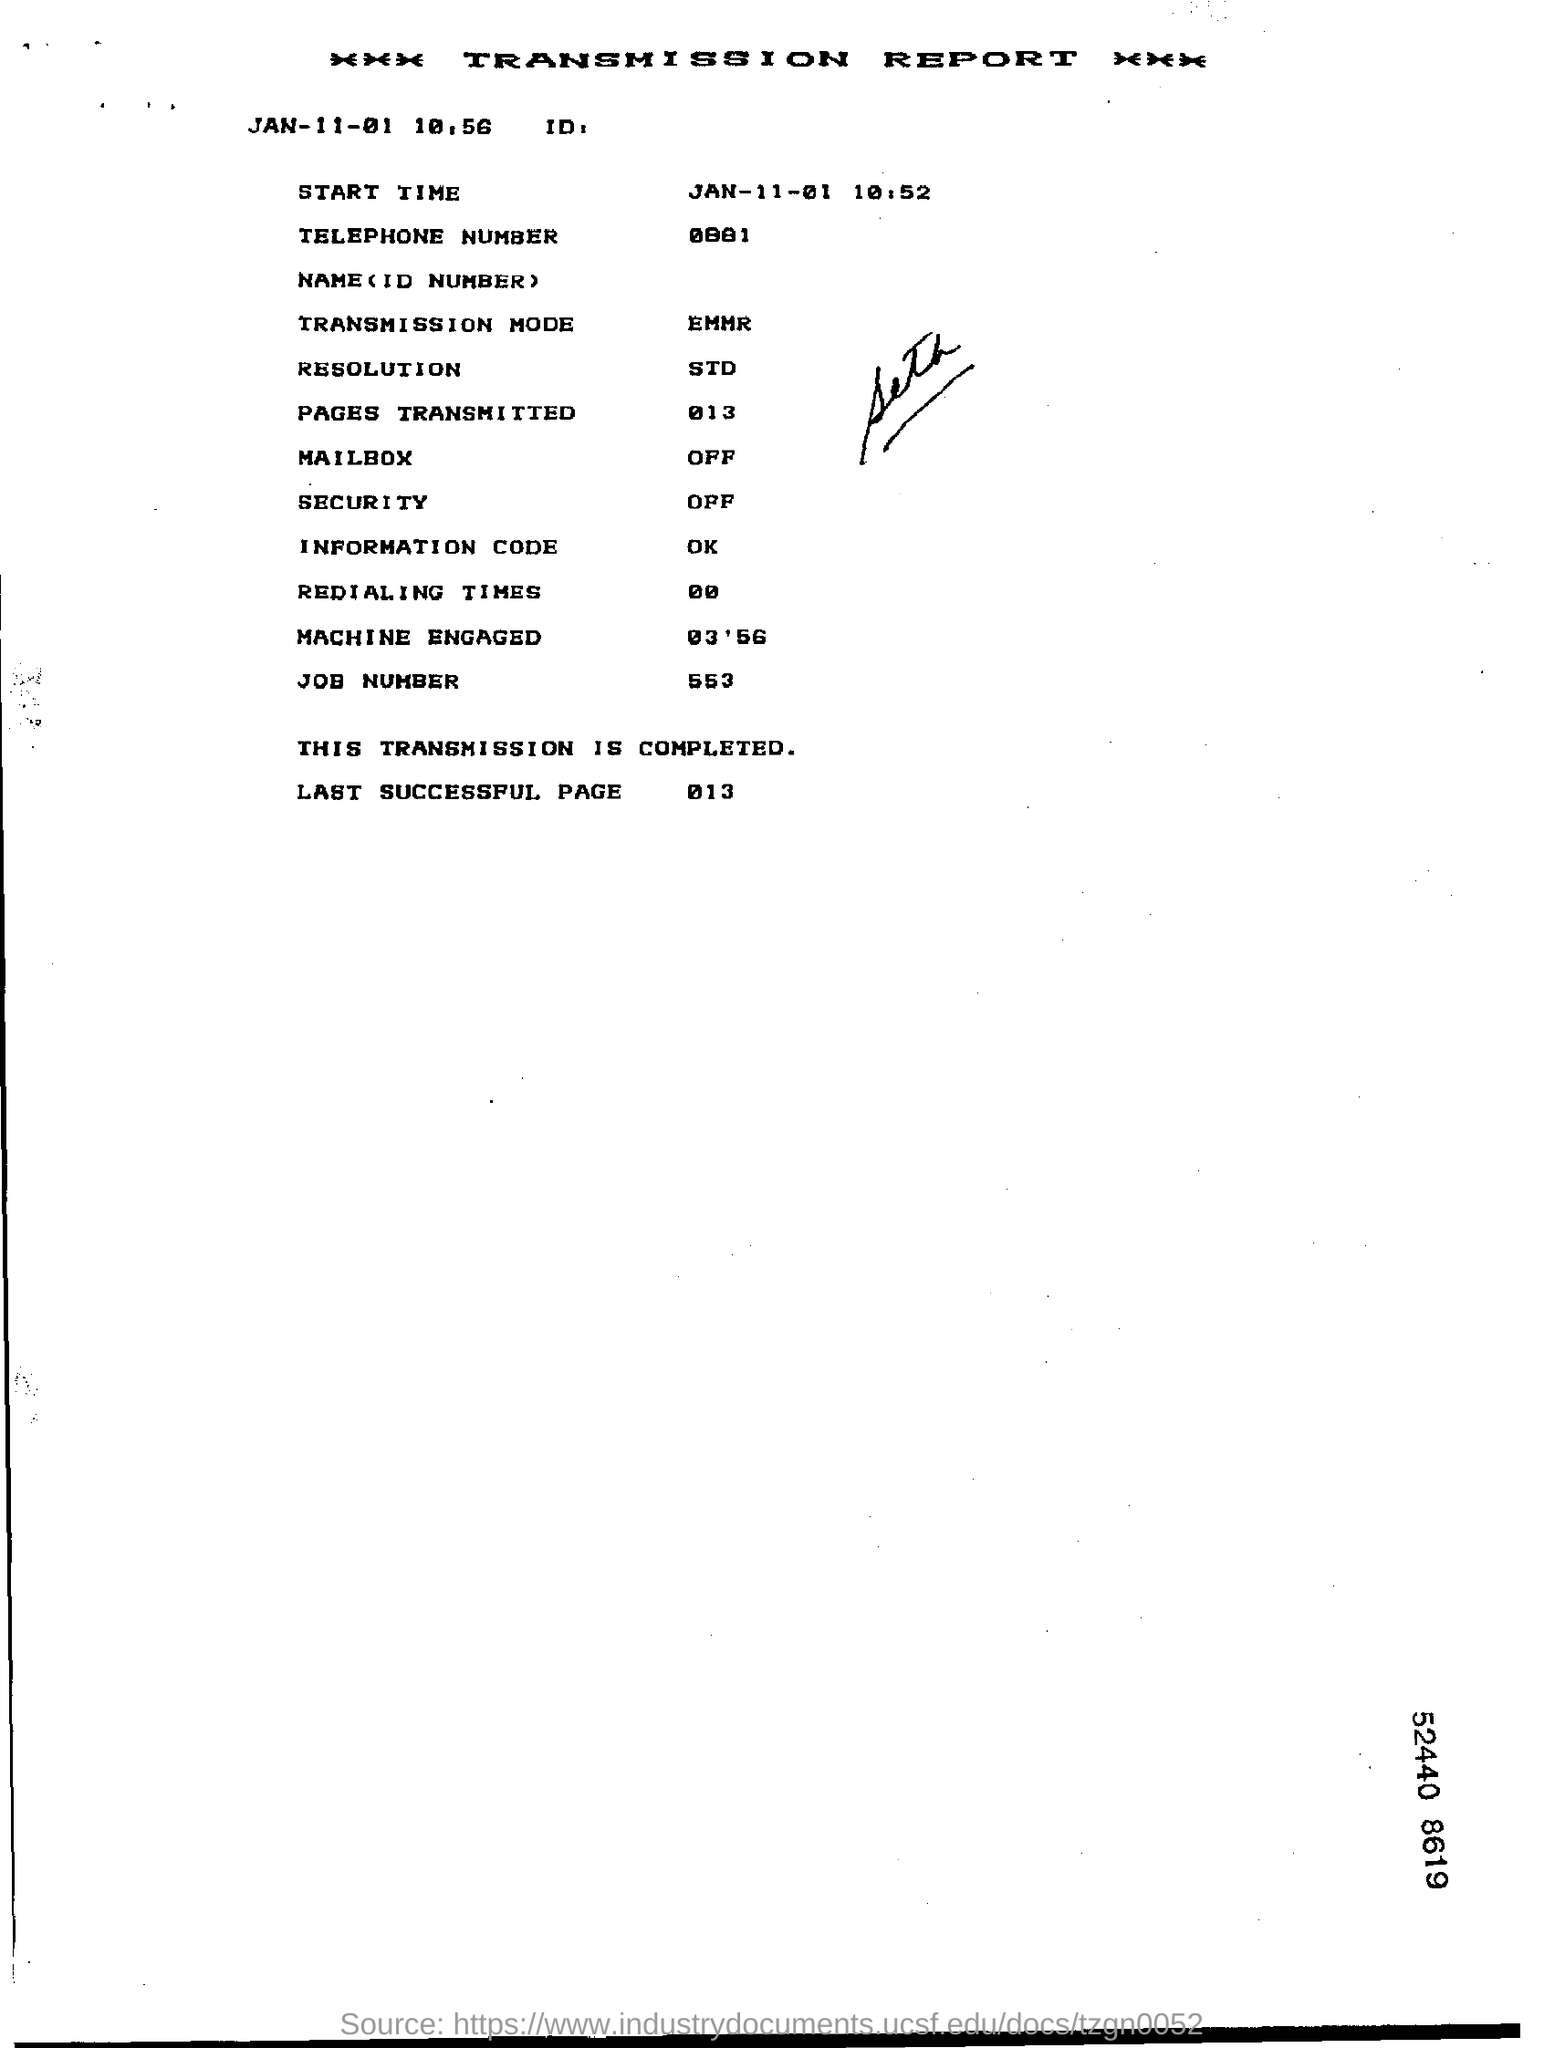Give some essential details in this illustration. The resolution is 300 dpi, which is a standard for image quality. The information code is... The transmission mode is EMMR. The job number is 553. The last successful page visited was 013. 